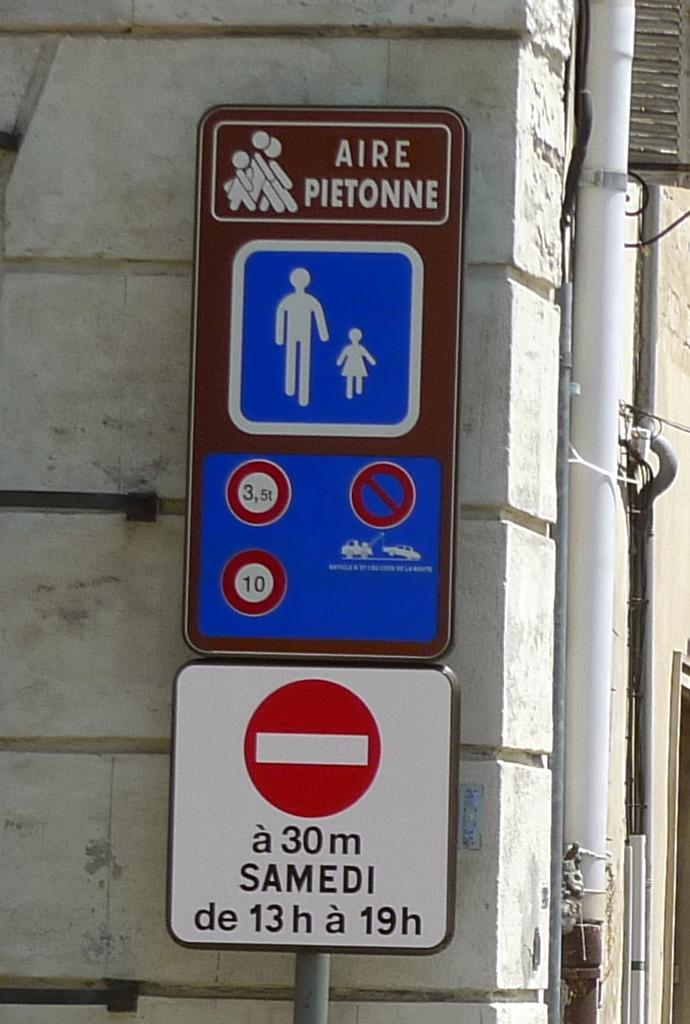<image>
Write a terse but informative summary of the picture. A street sign with the words "AIRE PIETONNE" 